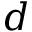Convert formula to latex. <formula><loc_0><loc_0><loc_500><loc_500>d</formula> 